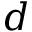Convert formula to latex. <formula><loc_0><loc_0><loc_500><loc_500>d</formula> 